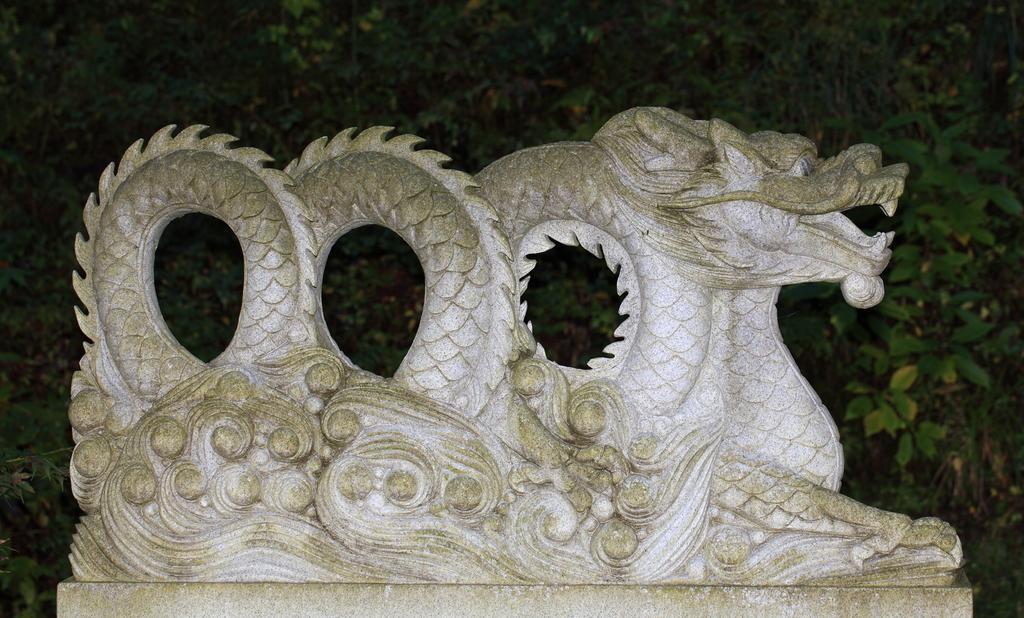What is the main subject in the foreground of the image? There is a sculpture in the foreground of the image. What can be seen in the background of the image? There are trees in the background of the image. What type of pen is being used to draw the sculpture in the image? There is no pen or drawing activity present in the image; it features a sculpture and trees in the background. 